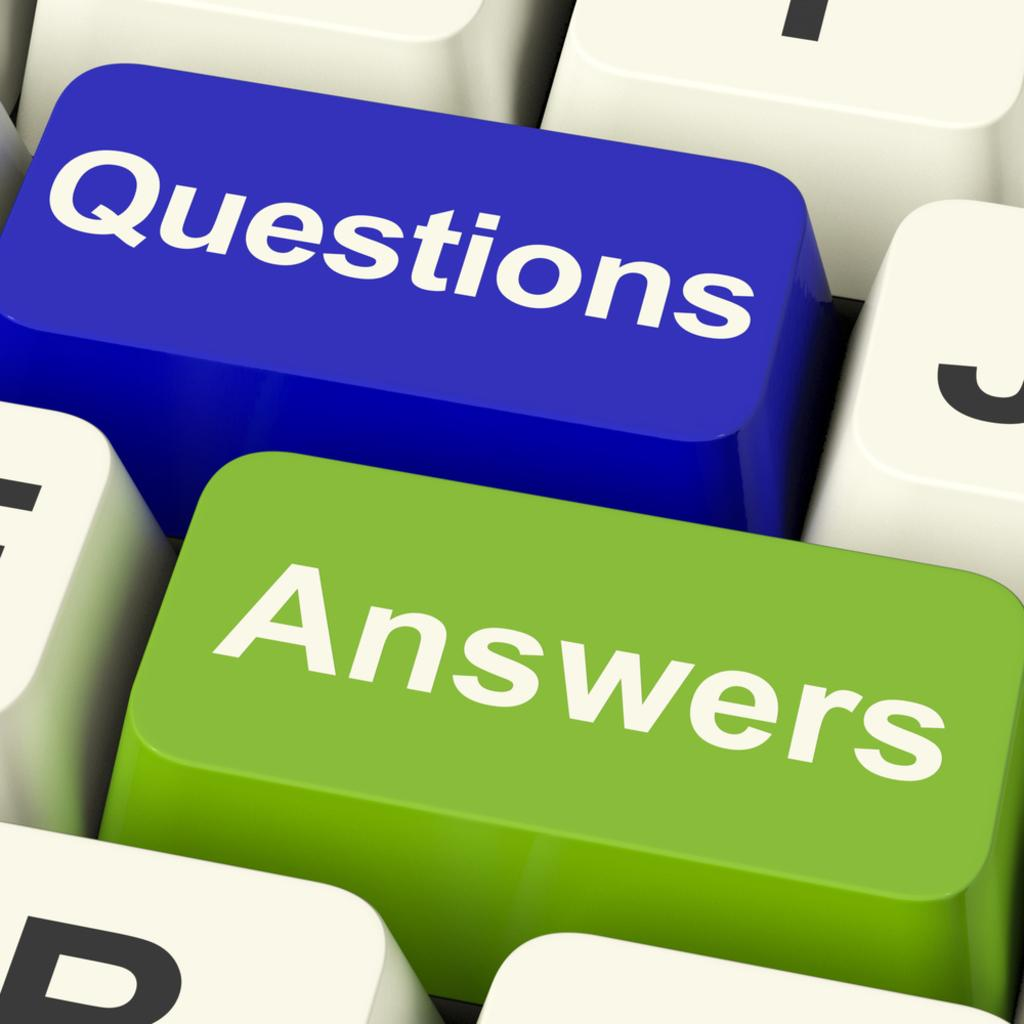<image>
Give a short and clear explanation of the subsequent image. a close up of a keyboard with keys Answers and Questions 